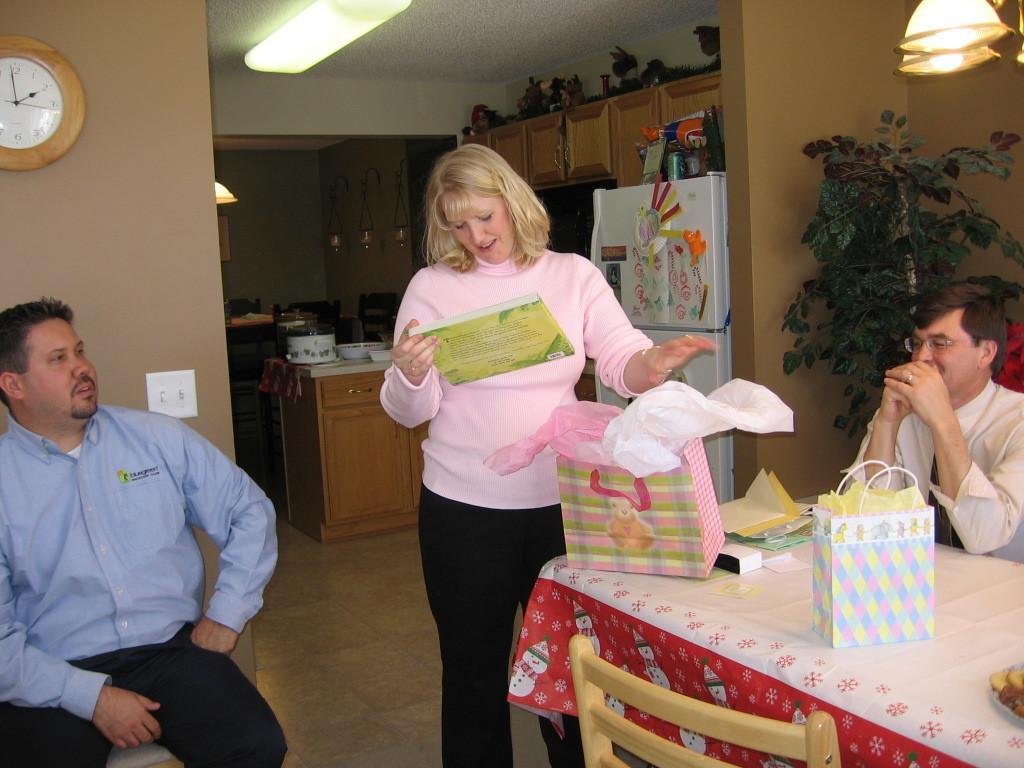Can you describe this image briefly? On the left side of the image we can see a person is sitting on the chair and a clock is there on the wall. In the middle of the image we can see a lady is holding something in her hand and fridge and cupboard is there. On the right side of the image we can see a person is sitting on chair and keeping his hands on the table, a plant and light is there. 